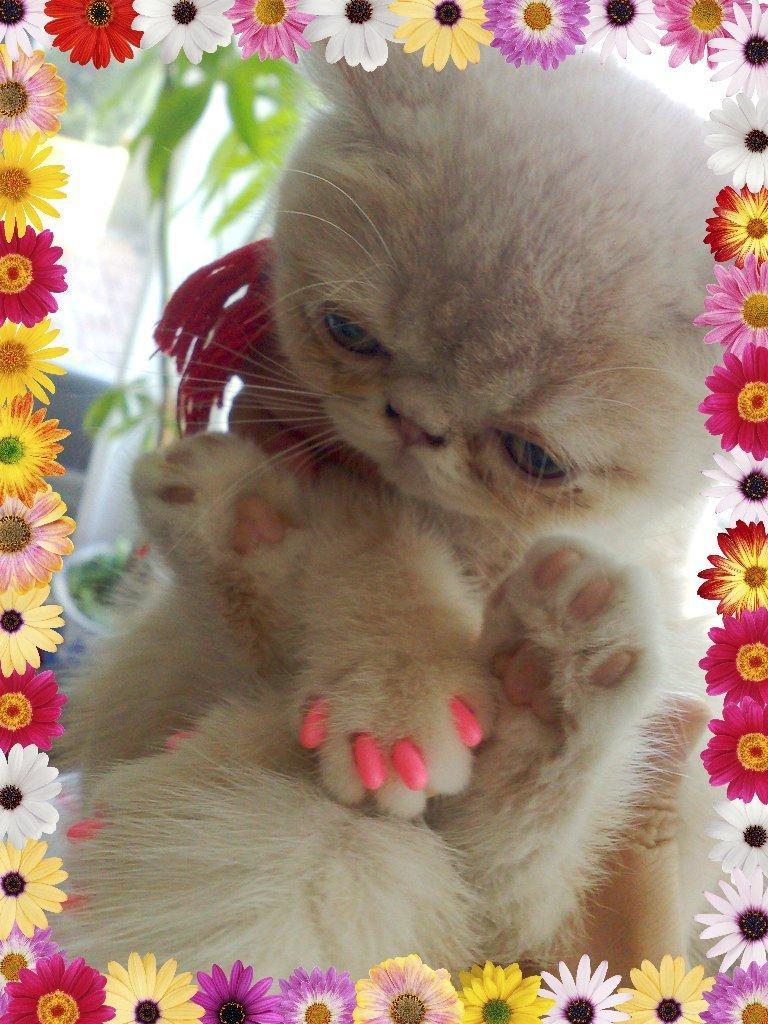Could you give a brief overview of what you see in this image? This picture shows a cat and we see a plant. The cat is a light brown in color and we see flowers around the picture. 